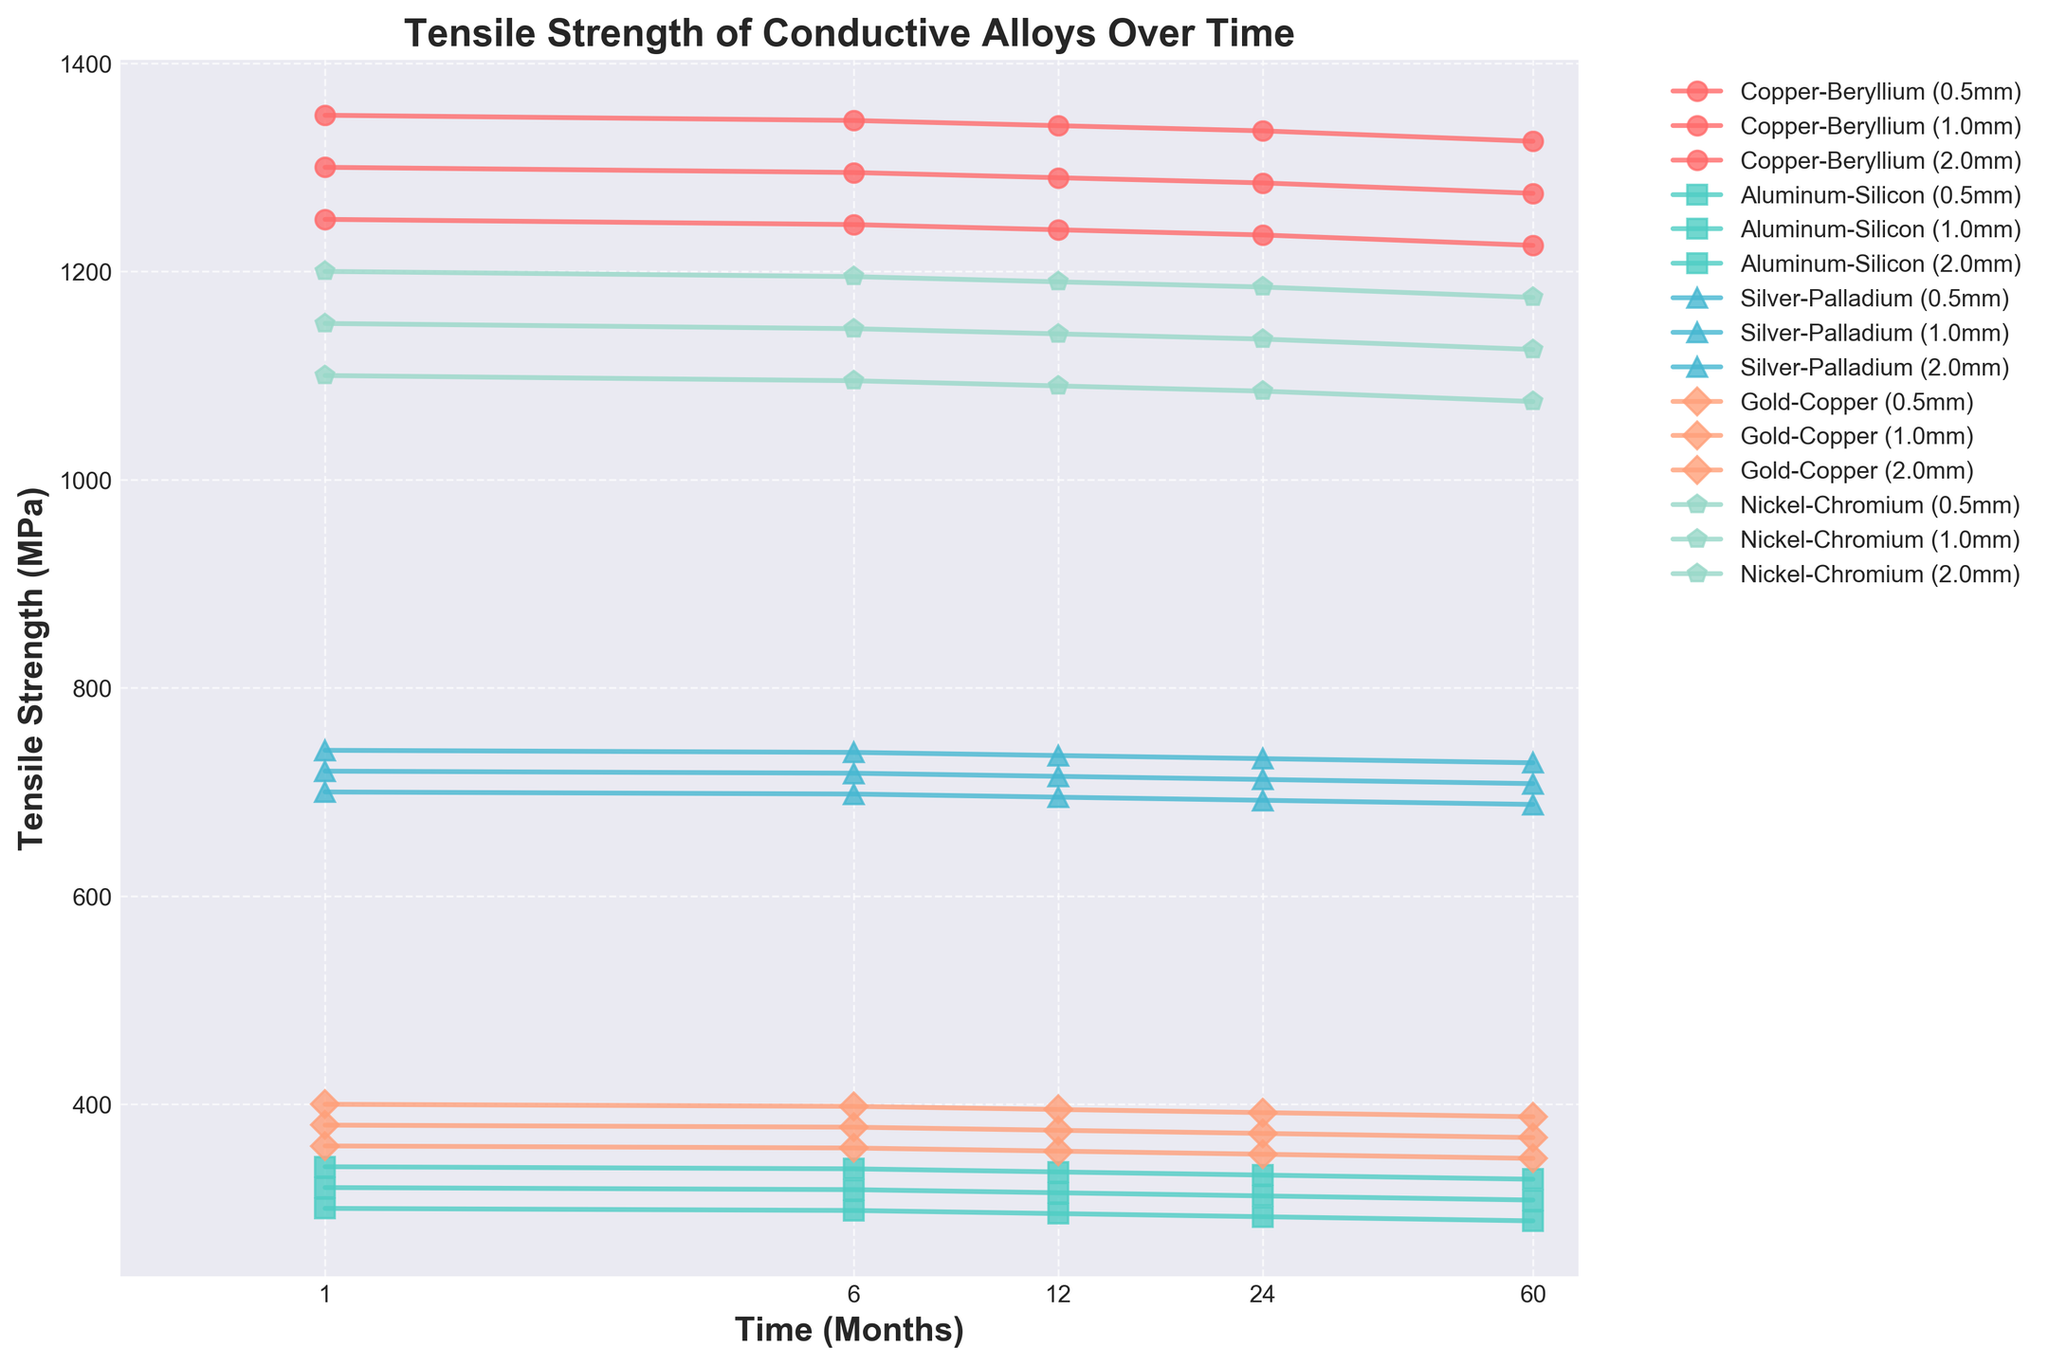What is the tensile strength of the 1.0mm Copper-Beryllium alloy after 2 years? First, locate the line and marker for Copper-Beryllium at 1.0mm thickness. Find the tensile strength value at the 24-month (2-year) point on this line.
Answer: 1285 MPa Which alloy shows the highest tensile strength at 1 month for the 2.0mm thickness? Look at the tensile strength values at 1 month for all alloys with a thickness of 2.0mm. Identify the maximum value.
Answer: Copper-Beryllium How does the tensile strength of Aluminum-Silicon alloy at 0.5mm thickness change from 1 month to 5 years? Locate the 0.5mm Aluminum-Silicon line. Find the tensile strength values at 1 month and at 5 years. Calculate the difference.
Answer: Decreases by 12 MPa Which alloy has the most stable tensile strength over 5 years at 0.5mm thickness? For each alloy at 0.5mm thickness, observe the changes in tensile strength over the 5-year period and identify the one with the least variation.
Answer: Copper-Beryllium Compare the tensile strength of Nickel-Chromium at 2.0mm and 1.0mm thickness after 5 years. Examine the tensile strength values for Nickel-Chromium at both 2.0mm and 1.0mm thicknesses at the 60-month (5-year) point and compare them.
Answer: 1175 MPa vs. 1125 MPa Between 1 year and 2 years, which alloy at 1.0mm thickness shows the largest decrease in tensile strength? For each alloy at 1.0mm thickness, find the tensile strength values at 12 months and 24 months. Calculate the difference and identify the largest decrement.
Answer: Nickel-Chromium What is the overall trend in tensile strength for Silver-Palladium alloy at different thicknesses over the 5-year period? Observe the lines for Silver-Palladium alloy at 0.5mm, 1.0mm, and 2.0mm thicknesses. Describe the general trend in tensile strength from 1 month to 5 years.
Answer: Gradually decreases Comparing the alloy with the highest tensile strength at 2.0mm thickness and 5 years to the alloy with the lowest tensile strength at the same thickness and period, what is the tensile strength difference? Identify the tensile strength values for the highest and lowest tensile strengths at 2.0mm thickness after 5 years. Calculate the difference.
Answer: 1325 MPa vs. 328 MPa, so the difference is 997 MPa Which alloy exhibits the largest drop in tensile strength from 1 month to 6 months at 1.0mm thickness? For each alloy at 1.0mm, calculate the difference in tensile strength from 1 month to 6 months and determine which alloy has the largest drop.
Answer: Copper-Beryllium How does the tensile strength of Gold-Copper at 0.5mm compared to Silver-Palladium at 1.0mm after 12 months? Look for the tensile strength of Gold-Copper at 0.5mm and Silver-Palladium at 1.0mm at the 12-month point and compare the two values.
Answer: 355 MPa vs. 715 MPa 